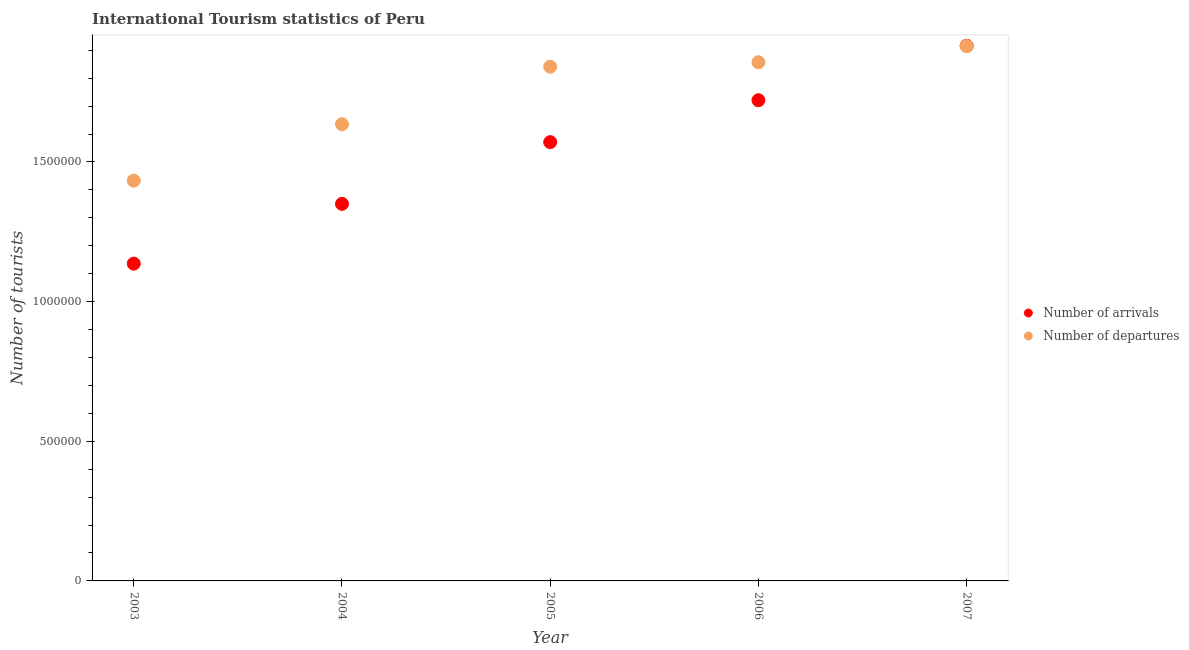How many different coloured dotlines are there?
Your response must be concise. 2. Is the number of dotlines equal to the number of legend labels?
Make the answer very short. Yes. What is the number of tourist arrivals in 2003?
Provide a succinct answer. 1.14e+06. Across all years, what is the maximum number of tourist departures?
Give a very brief answer. 1.92e+06. Across all years, what is the minimum number of tourist departures?
Ensure brevity in your answer.  1.43e+06. In which year was the number of tourist departures maximum?
Provide a short and direct response. 2007. What is the total number of tourist departures in the graph?
Ensure brevity in your answer.  8.68e+06. What is the difference between the number of tourist arrivals in 2004 and that in 2007?
Offer a terse response. -5.66e+05. What is the difference between the number of tourist arrivals in 2007 and the number of tourist departures in 2006?
Offer a terse response. 5.90e+04. What is the average number of tourist arrivals per year?
Your answer should be very brief. 1.54e+06. In the year 2005, what is the difference between the number of tourist departures and number of tourist arrivals?
Your answer should be compact. 2.70e+05. What is the ratio of the number of tourist departures in 2005 to that in 2006?
Offer a terse response. 0.99. Is the number of tourist arrivals in 2003 less than that in 2004?
Provide a succinct answer. Yes. What is the difference between the highest and the second highest number of tourist arrivals?
Keep it short and to the point. 1.95e+05. What is the difference between the highest and the lowest number of tourist arrivals?
Make the answer very short. 7.80e+05. In how many years, is the number of tourist departures greater than the average number of tourist departures taken over all years?
Provide a succinct answer. 3. Is the sum of the number of tourist arrivals in 2003 and 2006 greater than the maximum number of tourist departures across all years?
Your answer should be compact. Yes. Does the number of tourist departures monotonically increase over the years?
Provide a short and direct response. Yes. Is the number of tourist departures strictly greater than the number of tourist arrivals over the years?
Keep it short and to the point. No. How many dotlines are there?
Your answer should be compact. 2. Are the values on the major ticks of Y-axis written in scientific E-notation?
Your answer should be very brief. No. How many legend labels are there?
Make the answer very short. 2. What is the title of the graph?
Provide a short and direct response. International Tourism statistics of Peru. What is the label or title of the Y-axis?
Your response must be concise. Number of tourists. What is the Number of tourists in Number of arrivals in 2003?
Give a very brief answer. 1.14e+06. What is the Number of tourists of Number of departures in 2003?
Provide a short and direct response. 1.43e+06. What is the Number of tourists in Number of arrivals in 2004?
Make the answer very short. 1.35e+06. What is the Number of tourists in Number of departures in 2004?
Keep it short and to the point. 1.64e+06. What is the Number of tourists in Number of arrivals in 2005?
Give a very brief answer. 1.57e+06. What is the Number of tourists in Number of departures in 2005?
Your answer should be very brief. 1.84e+06. What is the Number of tourists of Number of arrivals in 2006?
Offer a terse response. 1.72e+06. What is the Number of tourists in Number of departures in 2006?
Your answer should be very brief. 1.86e+06. What is the Number of tourists of Number of arrivals in 2007?
Keep it short and to the point. 1.92e+06. What is the Number of tourists in Number of departures in 2007?
Ensure brevity in your answer.  1.92e+06. Across all years, what is the maximum Number of tourists of Number of arrivals?
Make the answer very short. 1.92e+06. Across all years, what is the maximum Number of tourists of Number of departures?
Provide a short and direct response. 1.92e+06. Across all years, what is the minimum Number of tourists in Number of arrivals?
Ensure brevity in your answer.  1.14e+06. Across all years, what is the minimum Number of tourists in Number of departures?
Make the answer very short. 1.43e+06. What is the total Number of tourists in Number of arrivals in the graph?
Your response must be concise. 7.69e+06. What is the total Number of tourists of Number of departures in the graph?
Keep it short and to the point. 8.68e+06. What is the difference between the Number of tourists of Number of arrivals in 2003 and that in 2004?
Your answer should be compact. -2.14e+05. What is the difference between the Number of tourists in Number of departures in 2003 and that in 2004?
Give a very brief answer. -2.02e+05. What is the difference between the Number of tourists in Number of arrivals in 2003 and that in 2005?
Provide a succinct answer. -4.35e+05. What is the difference between the Number of tourists of Number of departures in 2003 and that in 2005?
Provide a short and direct response. -4.08e+05. What is the difference between the Number of tourists in Number of arrivals in 2003 and that in 2006?
Provide a succinct answer. -5.85e+05. What is the difference between the Number of tourists of Number of departures in 2003 and that in 2006?
Your answer should be very brief. -4.24e+05. What is the difference between the Number of tourists in Number of arrivals in 2003 and that in 2007?
Offer a terse response. -7.80e+05. What is the difference between the Number of tourists in Number of departures in 2003 and that in 2007?
Provide a short and direct response. -4.82e+05. What is the difference between the Number of tourists of Number of arrivals in 2004 and that in 2005?
Ensure brevity in your answer.  -2.21e+05. What is the difference between the Number of tourists in Number of departures in 2004 and that in 2005?
Your answer should be very brief. -2.06e+05. What is the difference between the Number of tourists of Number of arrivals in 2004 and that in 2006?
Make the answer very short. -3.71e+05. What is the difference between the Number of tourists of Number of departures in 2004 and that in 2006?
Offer a very short reply. -2.22e+05. What is the difference between the Number of tourists in Number of arrivals in 2004 and that in 2007?
Provide a succinct answer. -5.66e+05. What is the difference between the Number of tourists of Number of departures in 2004 and that in 2007?
Give a very brief answer. -2.80e+05. What is the difference between the Number of tourists in Number of arrivals in 2005 and that in 2006?
Offer a very short reply. -1.50e+05. What is the difference between the Number of tourists of Number of departures in 2005 and that in 2006?
Your answer should be very brief. -1.60e+04. What is the difference between the Number of tourists in Number of arrivals in 2005 and that in 2007?
Give a very brief answer. -3.45e+05. What is the difference between the Number of tourists in Number of departures in 2005 and that in 2007?
Your answer should be compact. -7.40e+04. What is the difference between the Number of tourists of Number of arrivals in 2006 and that in 2007?
Keep it short and to the point. -1.95e+05. What is the difference between the Number of tourists in Number of departures in 2006 and that in 2007?
Give a very brief answer. -5.80e+04. What is the difference between the Number of tourists of Number of arrivals in 2003 and the Number of tourists of Number of departures in 2004?
Your answer should be compact. -4.99e+05. What is the difference between the Number of tourists of Number of arrivals in 2003 and the Number of tourists of Number of departures in 2005?
Offer a terse response. -7.05e+05. What is the difference between the Number of tourists of Number of arrivals in 2003 and the Number of tourists of Number of departures in 2006?
Offer a very short reply. -7.21e+05. What is the difference between the Number of tourists in Number of arrivals in 2003 and the Number of tourists in Number of departures in 2007?
Provide a succinct answer. -7.79e+05. What is the difference between the Number of tourists of Number of arrivals in 2004 and the Number of tourists of Number of departures in 2005?
Give a very brief answer. -4.91e+05. What is the difference between the Number of tourists of Number of arrivals in 2004 and the Number of tourists of Number of departures in 2006?
Ensure brevity in your answer.  -5.07e+05. What is the difference between the Number of tourists in Number of arrivals in 2004 and the Number of tourists in Number of departures in 2007?
Give a very brief answer. -5.65e+05. What is the difference between the Number of tourists in Number of arrivals in 2005 and the Number of tourists in Number of departures in 2006?
Offer a terse response. -2.86e+05. What is the difference between the Number of tourists in Number of arrivals in 2005 and the Number of tourists in Number of departures in 2007?
Your response must be concise. -3.44e+05. What is the difference between the Number of tourists in Number of arrivals in 2006 and the Number of tourists in Number of departures in 2007?
Provide a succinct answer. -1.94e+05. What is the average Number of tourists in Number of arrivals per year?
Provide a short and direct response. 1.54e+06. What is the average Number of tourists of Number of departures per year?
Offer a very short reply. 1.74e+06. In the year 2003, what is the difference between the Number of tourists of Number of arrivals and Number of tourists of Number of departures?
Make the answer very short. -2.97e+05. In the year 2004, what is the difference between the Number of tourists in Number of arrivals and Number of tourists in Number of departures?
Give a very brief answer. -2.85e+05. In the year 2006, what is the difference between the Number of tourists in Number of arrivals and Number of tourists in Number of departures?
Your answer should be very brief. -1.36e+05. In the year 2007, what is the difference between the Number of tourists of Number of arrivals and Number of tourists of Number of departures?
Give a very brief answer. 1000. What is the ratio of the Number of tourists in Number of arrivals in 2003 to that in 2004?
Offer a terse response. 0.84. What is the ratio of the Number of tourists of Number of departures in 2003 to that in 2004?
Make the answer very short. 0.88. What is the ratio of the Number of tourists in Number of arrivals in 2003 to that in 2005?
Offer a terse response. 0.72. What is the ratio of the Number of tourists in Number of departures in 2003 to that in 2005?
Your response must be concise. 0.78. What is the ratio of the Number of tourists of Number of arrivals in 2003 to that in 2006?
Your response must be concise. 0.66. What is the ratio of the Number of tourists in Number of departures in 2003 to that in 2006?
Make the answer very short. 0.77. What is the ratio of the Number of tourists in Number of arrivals in 2003 to that in 2007?
Offer a very short reply. 0.59. What is the ratio of the Number of tourists of Number of departures in 2003 to that in 2007?
Your response must be concise. 0.75. What is the ratio of the Number of tourists of Number of arrivals in 2004 to that in 2005?
Your answer should be compact. 0.86. What is the ratio of the Number of tourists in Number of departures in 2004 to that in 2005?
Give a very brief answer. 0.89. What is the ratio of the Number of tourists of Number of arrivals in 2004 to that in 2006?
Ensure brevity in your answer.  0.78. What is the ratio of the Number of tourists in Number of departures in 2004 to that in 2006?
Keep it short and to the point. 0.88. What is the ratio of the Number of tourists in Number of arrivals in 2004 to that in 2007?
Your response must be concise. 0.7. What is the ratio of the Number of tourists in Number of departures in 2004 to that in 2007?
Offer a terse response. 0.85. What is the ratio of the Number of tourists of Number of arrivals in 2005 to that in 2006?
Provide a succinct answer. 0.91. What is the ratio of the Number of tourists in Number of arrivals in 2005 to that in 2007?
Provide a succinct answer. 0.82. What is the ratio of the Number of tourists of Number of departures in 2005 to that in 2007?
Your response must be concise. 0.96. What is the ratio of the Number of tourists in Number of arrivals in 2006 to that in 2007?
Your answer should be very brief. 0.9. What is the ratio of the Number of tourists of Number of departures in 2006 to that in 2007?
Your answer should be very brief. 0.97. What is the difference between the highest and the second highest Number of tourists of Number of arrivals?
Give a very brief answer. 1.95e+05. What is the difference between the highest and the second highest Number of tourists in Number of departures?
Keep it short and to the point. 5.80e+04. What is the difference between the highest and the lowest Number of tourists in Number of arrivals?
Your answer should be compact. 7.80e+05. What is the difference between the highest and the lowest Number of tourists of Number of departures?
Give a very brief answer. 4.82e+05. 